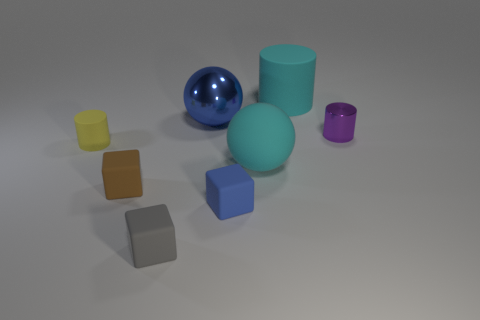There is a thing that is the same color as the large shiny ball; what is its size?
Keep it short and to the point. Small. The ball that is the same material as the large cylinder is what size?
Ensure brevity in your answer.  Large. Are there an equal number of blue metal spheres in front of the gray object and things in front of the shiny ball?
Your response must be concise. No. There is a small matte object behind the brown rubber thing; what color is it?
Offer a very short reply. Yellow. Is the color of the rubber sphere the same as the object that is behind the big blue metallic ball?
Offer a terse response. Yes. Is the number of large shiny balls less than the number of big green metal cubes?
Your response must be concise. No. Do the matte cylinder that is behind the purple cylinder and the large matte ball have the same color?
Your response must be concise. Yes. How many blue metallic balls are the same size as the purple metal object?
Give a very brief answer. 0. Is there a large shiny object of the same color as the rubber sphere?
Give a very brief answer. No. Do the small brown block and the big cylinder have the same material?
Offer a very short reply. Yes. 